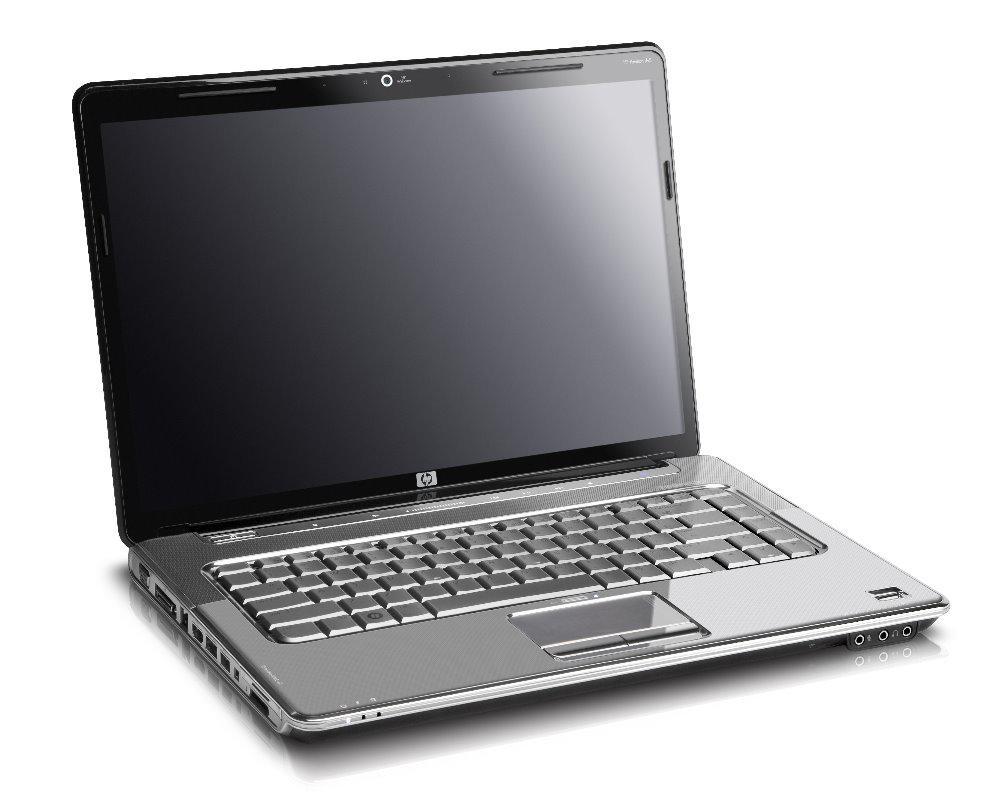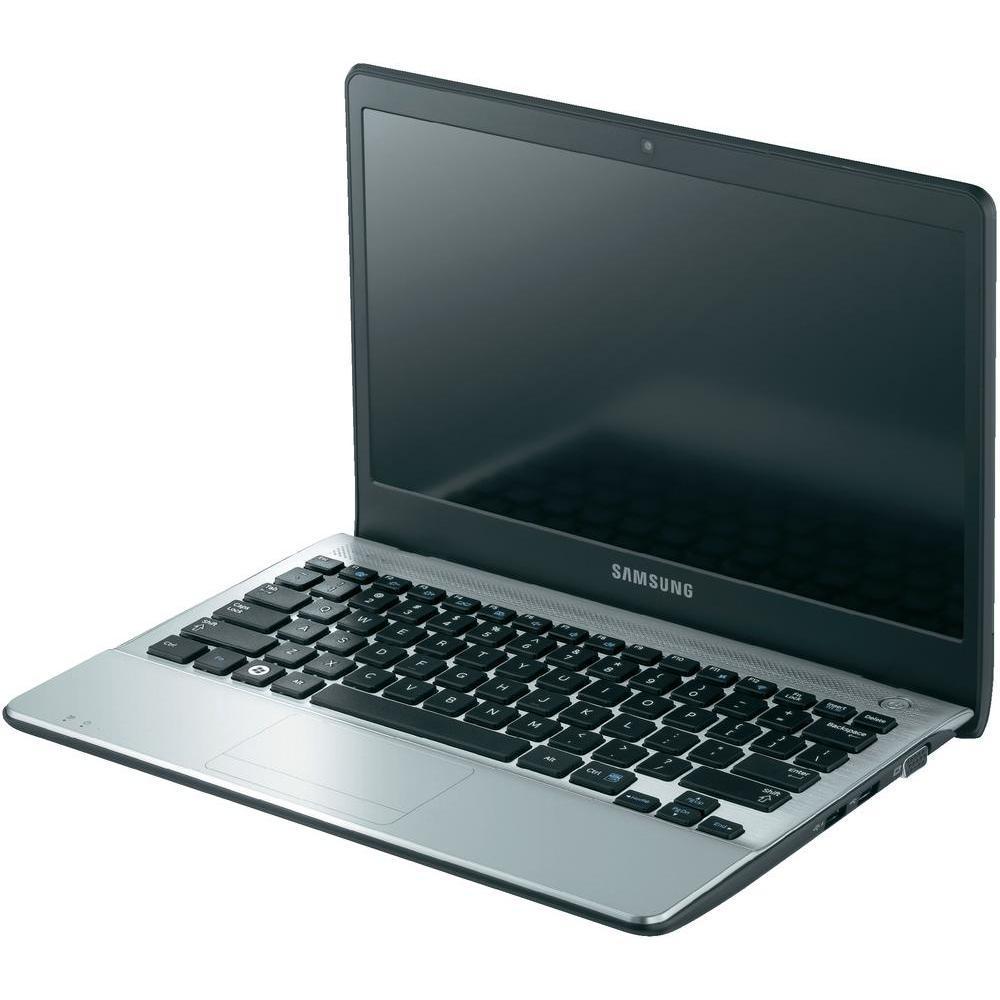The first image is the image on the left, the second image is the image on the right. Assess this claim about the two images: "Every single laptop appears to be powered on right now.". Correct or not? Answer yes or no. No. The first image is the image on the left, the second image is the image on the right. Given the left and right images, does the statement "The open laptop on the left is displayed head-on, while the one on the right is turned at an angle." hold true? Answer yes or no. No. 